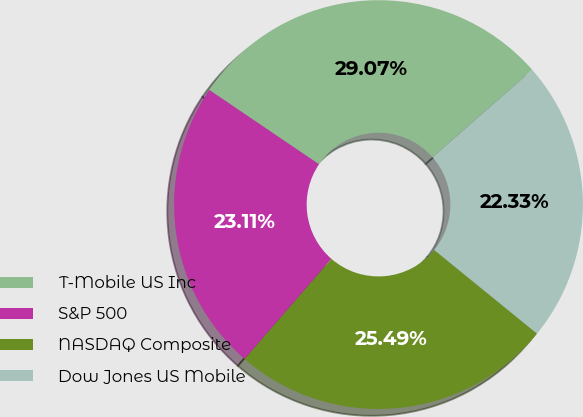Convert chart. <chart><loc_0><loc_0><loc_500><loc_500><pie_chart><fcel>T-Mobile US Inc<fcel>S&P 500<fcel>NASDAQ Composite<fcel>Dow Jones US Mobile<nl><fcel>29.07%<fcel>23.11%<fcel>25.49%<fcel>22.33%<nl></chart> 